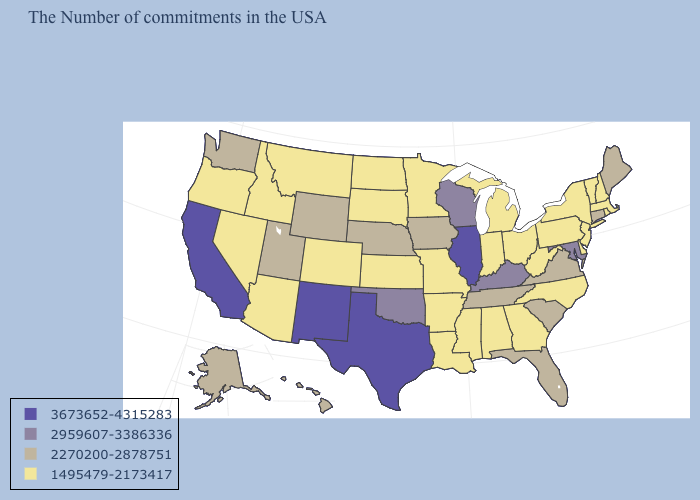Name the states that have a value in the range 2270200-2878751?
Give a very brief answer. Maine, Connecticut, Virginia, South Carolina, Florida, Tennessee, Iowa, Nebraska, Wyoming, Utah, Washington, Alaska, Hawaii. Does New Hampshire have the lowest value in the USA?
Give a very brief answer. Yes. Does the map have missing data?
Write a very short answer. No. Name the states that have a value in the range 3673652-4315283?
Answer briefly. Illinois, Texas, New Mexico, California. Is the legend a continuous bar?
Short answer required. No. What is the value of Connecticut?
Be succinct. 2270200-2878751. Does Wyoming have a higher value than Minnesota?
Keep it brief. Yes. Name the states that have a value in the range 1495479-2173417?
Keep it brief. Massachusetts, Rhode Island, New Hampshire, Vermont, New York, New Jersey, Delaware, Pennsylvania, North Carolina, West Virginia, Ohio, Georgia, Michigan, Indiana, Alabama, Mississippi, Louisiana, Missouri, Arkansas, Minnesota, Kansas, South Dakota, North Dakota, Colorado, Montana, Arizona, Idaho, Nevada, Oregon. Does Hawaii have the same value as Vermont?
Concise answer only. No. Name the states that have a value in the range 3673652-4315283?
Give a very brief answer. Illinois, Texas, New Mexico, California. Does Illinois have the highest value in the MidWest?
Quick response, please. Yes. Does North Dakota have the lowest value in the USA?
Answer briefly. Yes. What is the highest value in the USA?
Answer briefly. 3673652-4315283. What is the highest value in the USA?
Be succinct. 3673652-4315283. What is the value of Ohio?
Answer briefly. 1495479-2173417. 